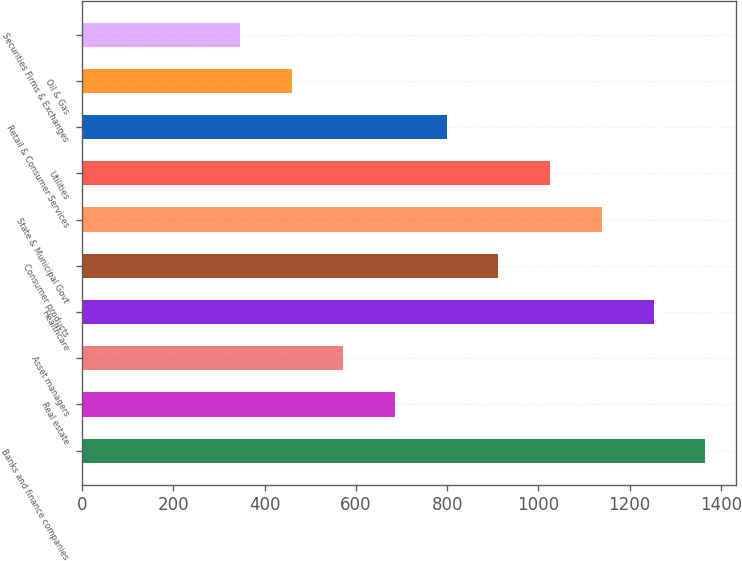<chart> <loc_0><loc_0><loc_500><loc_500><bar_chart><fcel>Banks and finance companies<fcel>Real estate<fcel>Asset managers<fcel>Healthcare<fcel>Consumer products<fcel>State & Municipal Govt<fcel>Utilities<fcel>Retail & Consumer Services<fcel>Oil & Gas<fcel>Securities Firms & Exchanges<nl><fcel>1365.4<fcel>685.9<fcel>572.65<fcel>1252.15<fcel>912.4<fcel>1138.9<fcel>1025.65<fcel>799.15<fcel>459.4<fcel>346.15<nl></chart> 